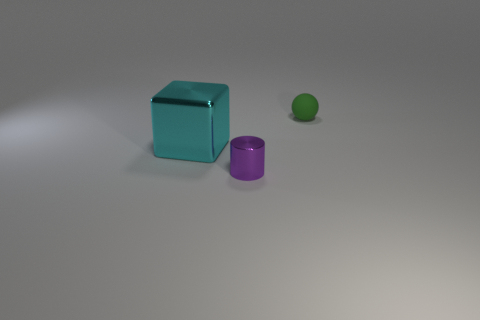Add 3 tiny metal objects. How many objects exist? 6 Subtract all cylinders. How many objects are left? 2 Add 1 small shiny things. How many small shiny things are left? 2 Add 1 cyan cubes. How many cyan cubes exist? 2 Subtract 0 blue spheres. How many objects are left? 3 Subtract all gray rubber spheres. Subtract all tiny objects. How many objects are left? 1 